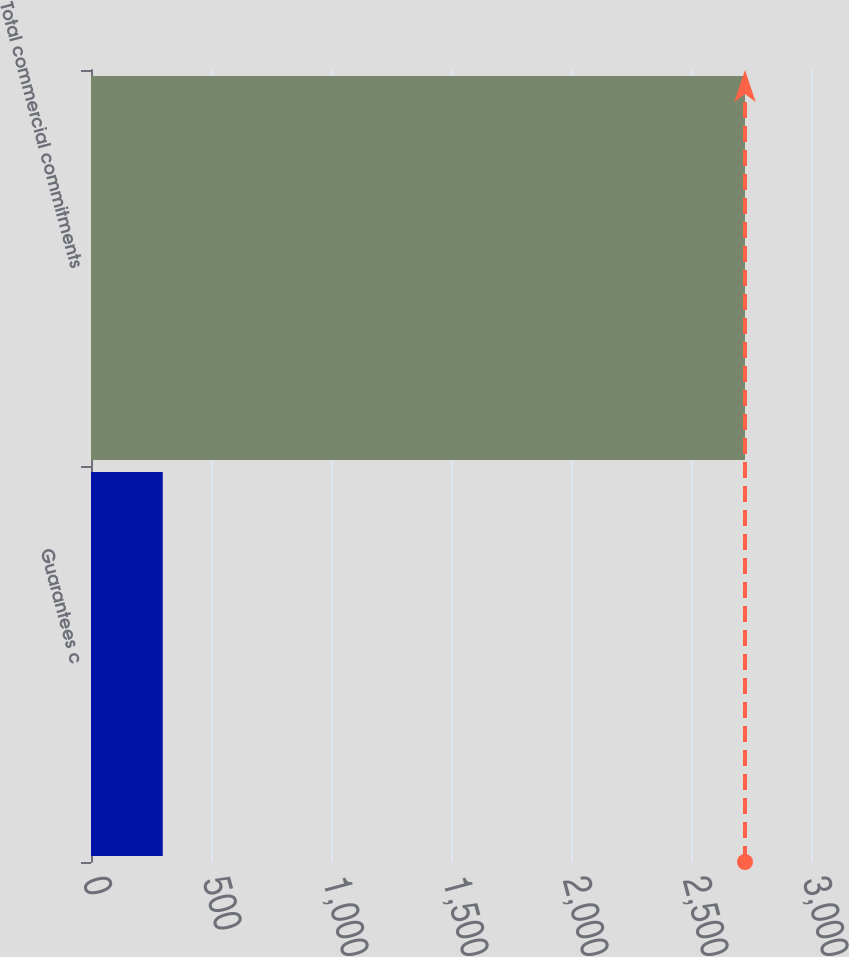Convert chart to OTSL. <chart><loc_0><loc_0><loc_500><loc_500><bar_chart><fcel>Guarantees c<fcel>Total commercial commitments<nl><fcel>299<fcel>2725<nl></chart> 